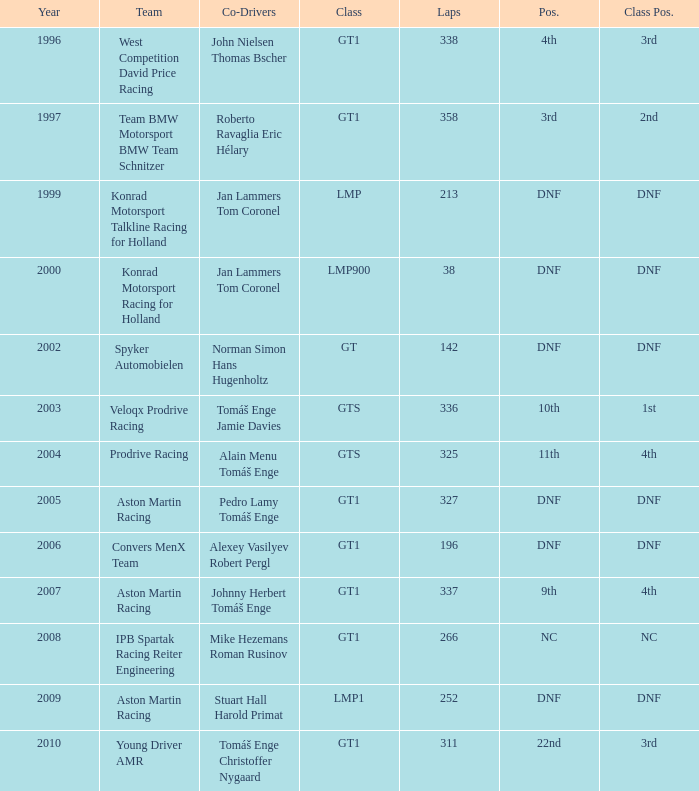Which team achieved a 3rd place finish in their class with 337 laps before the year 2008? West Competition David Price Racing. 